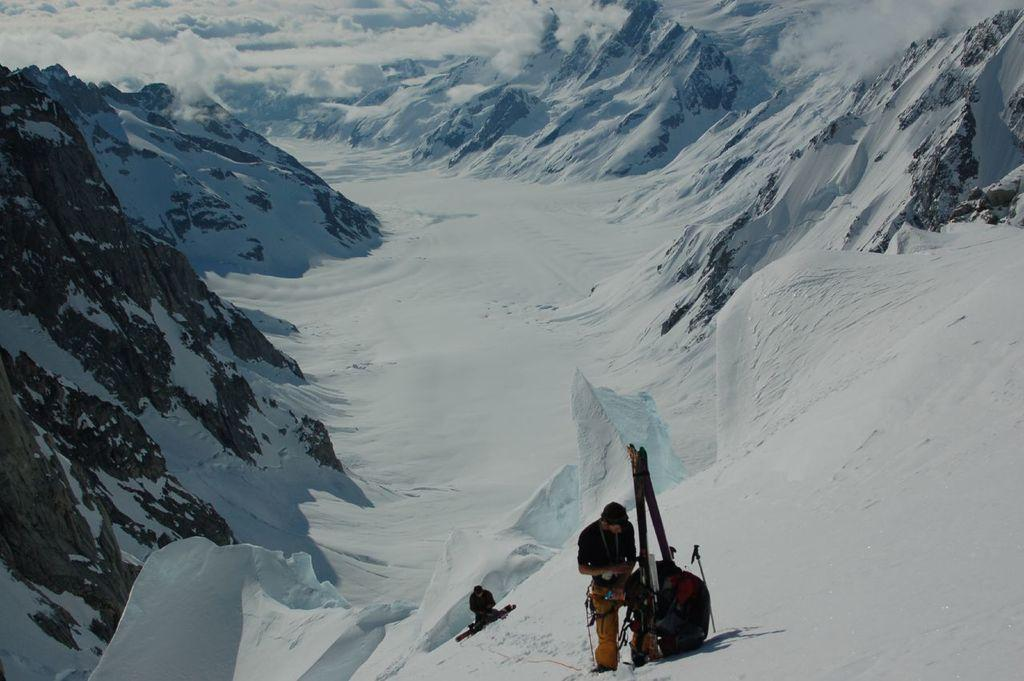What type of landscape is depicted in the image? There are mountains with snow in the image. What atmospheric condition is present in the image? There is fog in the image. Can you describe the people visible in the image? There are two people visible at the bottom of the image. What objects can be seen on the snow at the bottom of the image? There are objects on the snow at the bottom of the image. What committee is responsible for organizing the attack in the image? There is no attack or committee present in the image; it depicts a snowy mountain landscape with fog and people. 